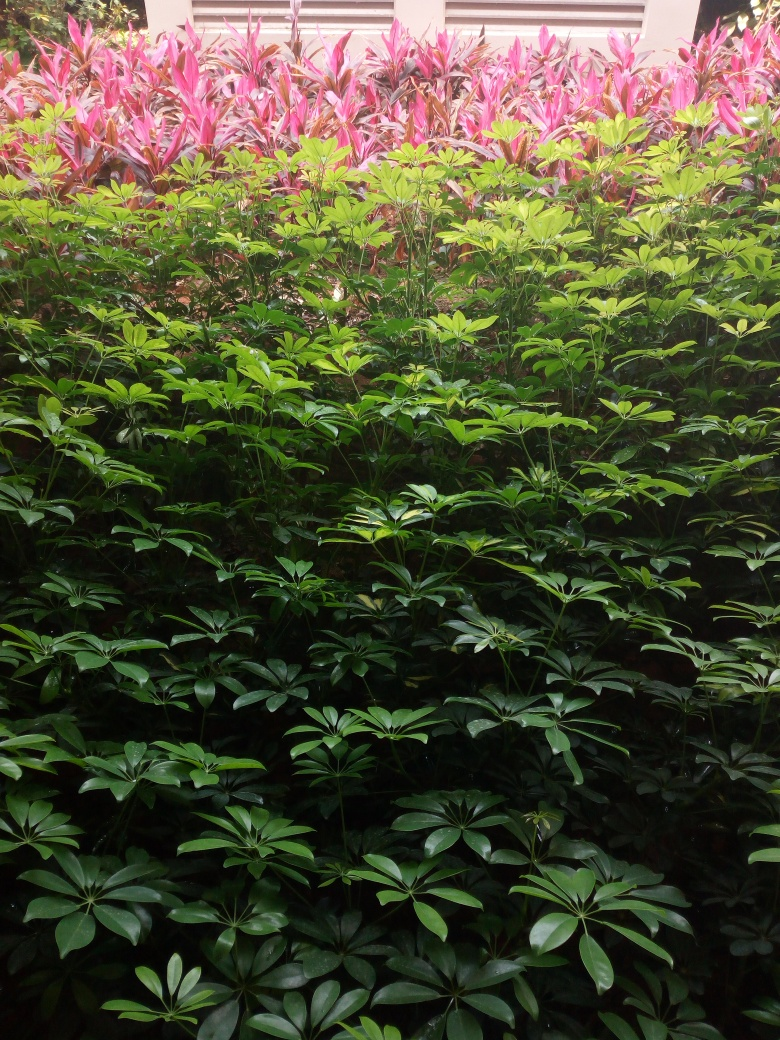What could be the ideal conditions for maintaining the health of these plants? The ideal conditions for these plants typically include partial to full indirect sunlight, consistent moisture with well-draining soil, and temperatures that mimic a tropical or subtropical climate. Regular fertilization during the growing season and protection from extreme temperatures and pests also contribute to their vibrant appearance. 